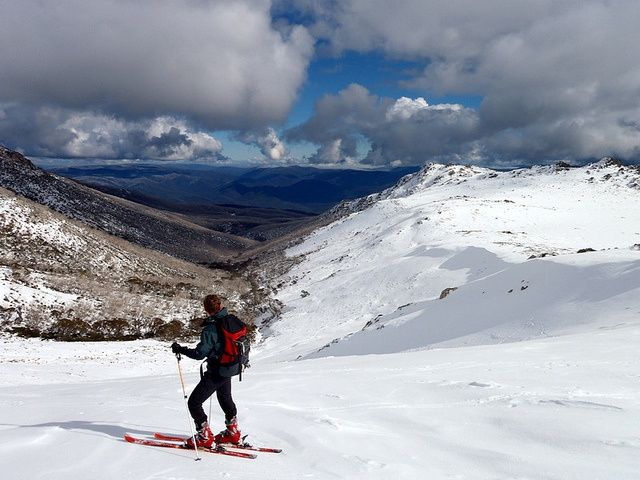Describe the objects in this image and their specific colors. I can see people in darkgray, black, maroon, and gray tones, backpack in darkgray, black, maroon, and gray tones, and skis in darkgray, brown, and maroon tones in this image. 